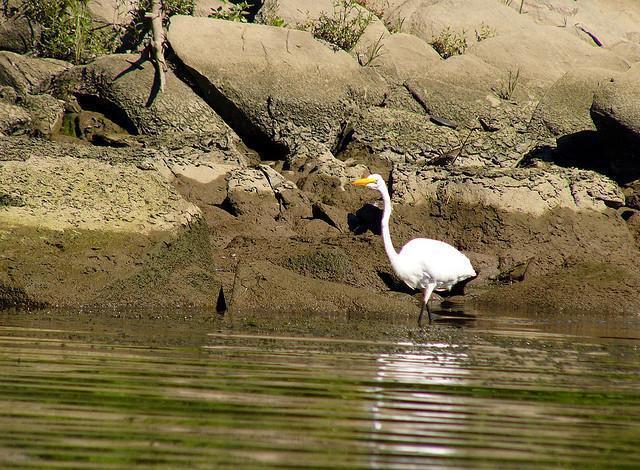How many animal are there?
Give a very brief answer. 1. How many people are wearing glasses?
Give a very brief answer. 0. 